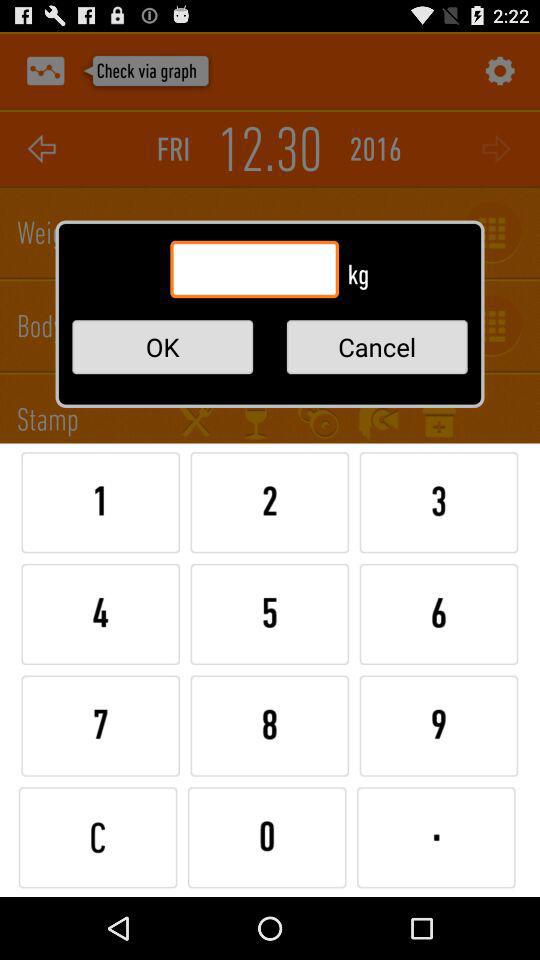What year is selected on the screen? The selected year on the screen is 2016. 